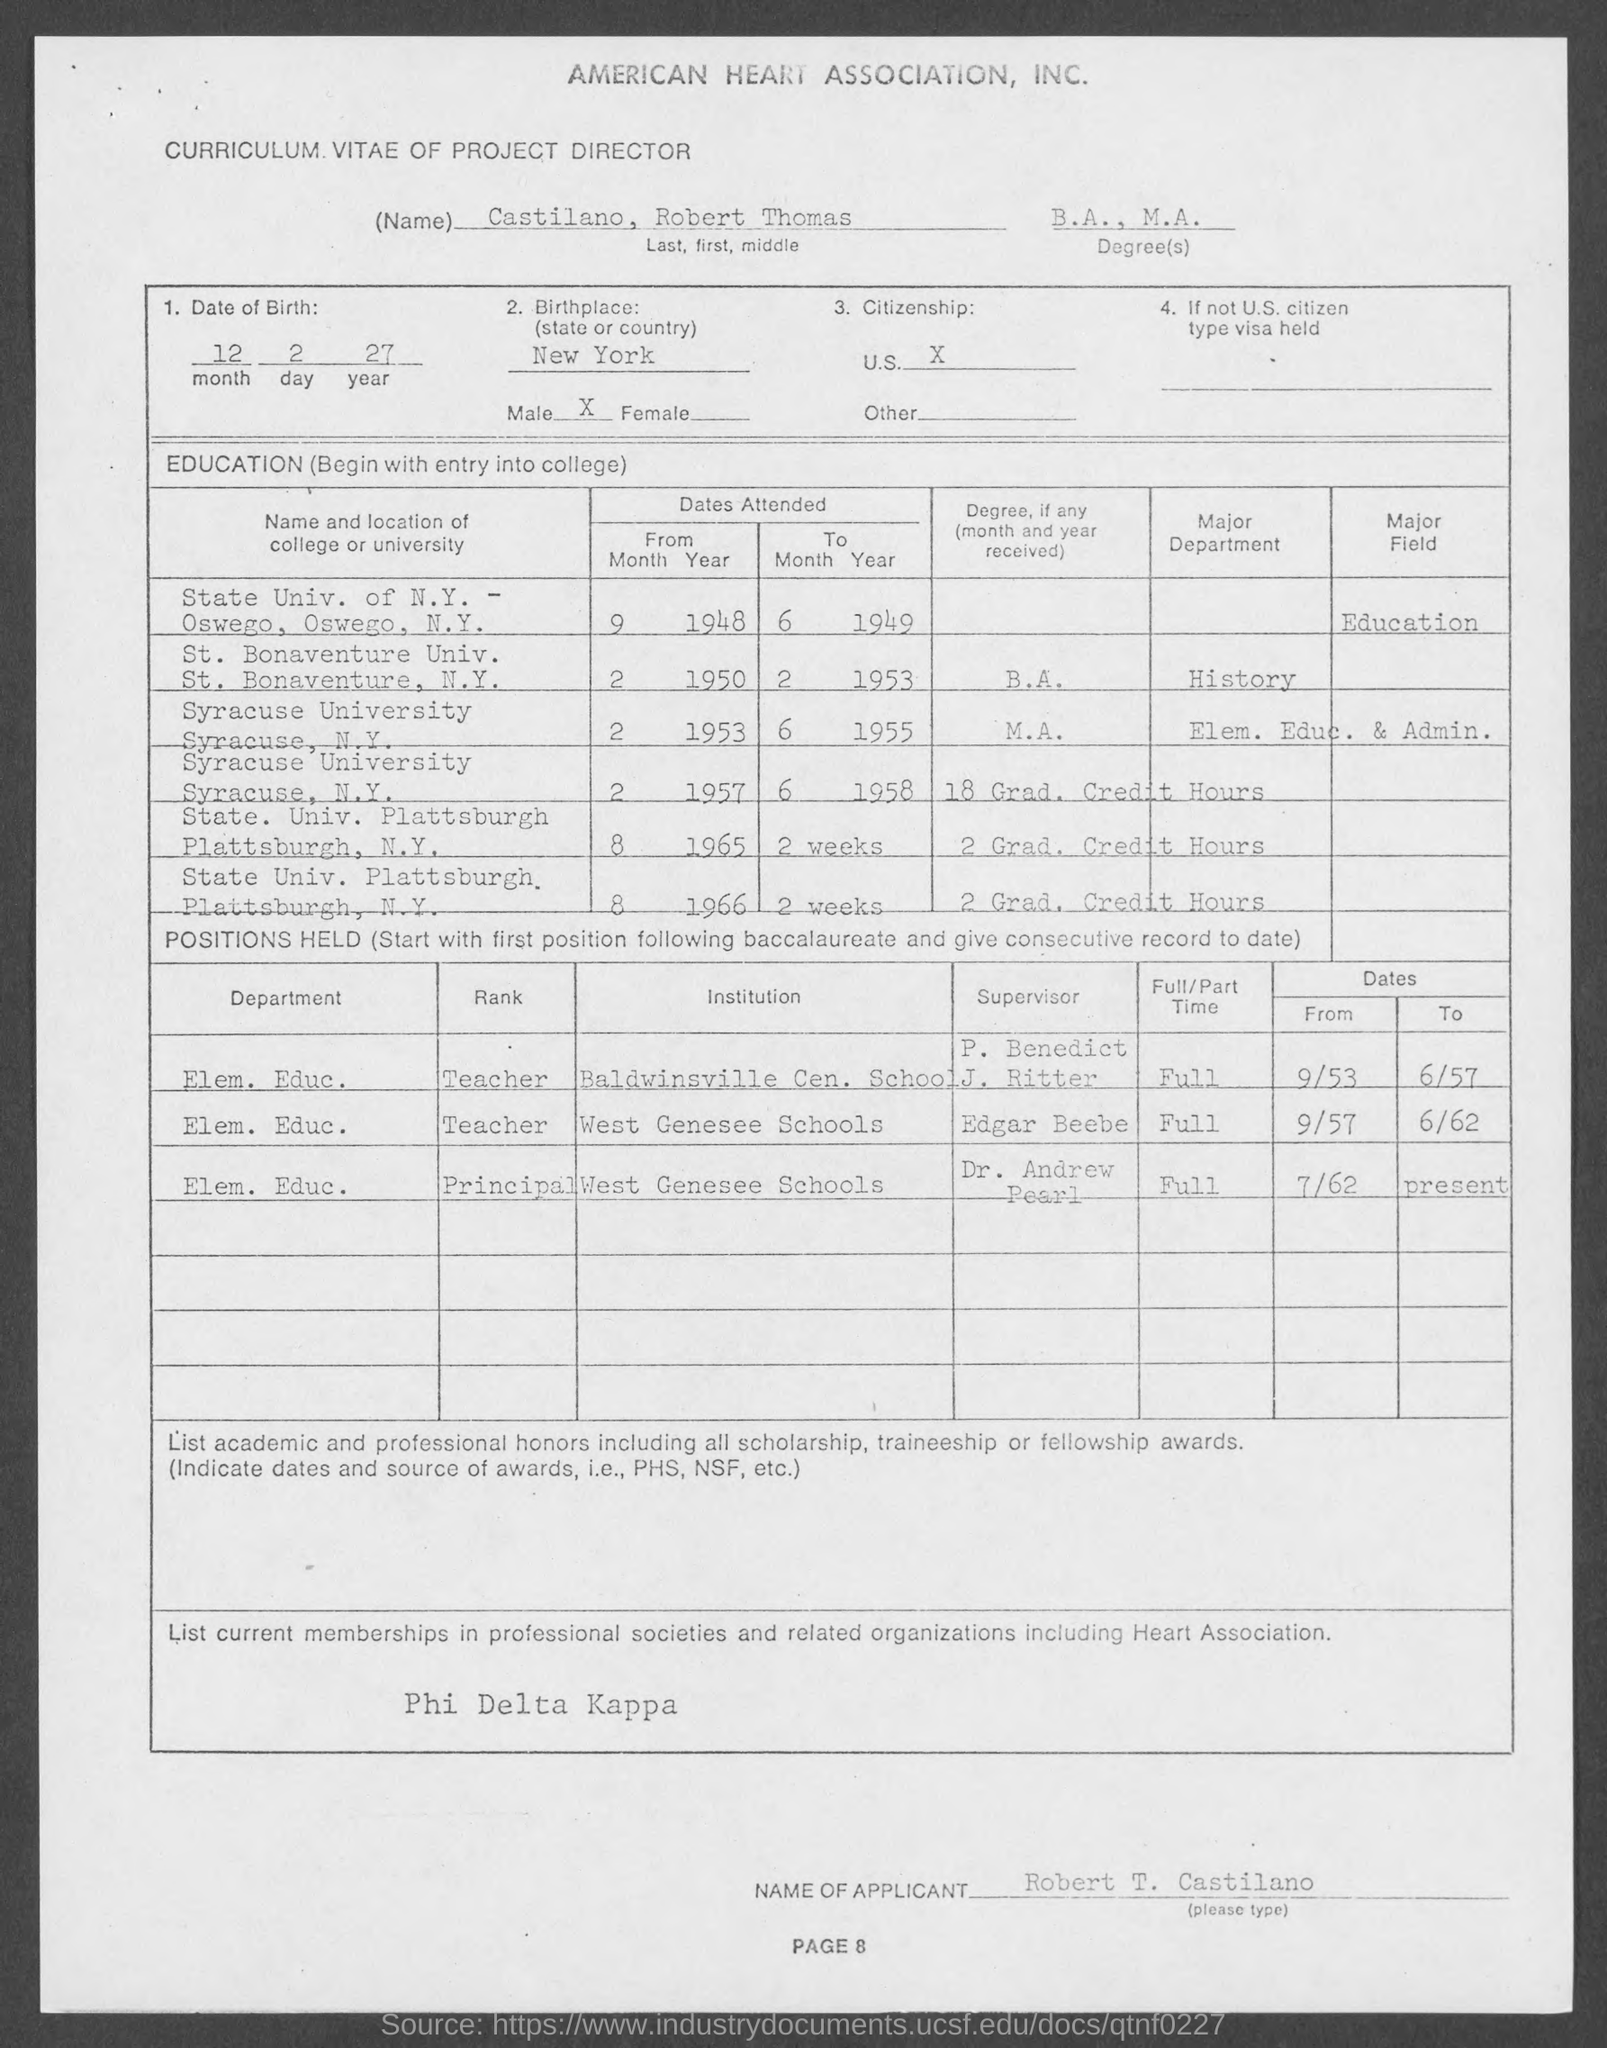Outline some significant characteristics in this image. The degrees offered are Bachelor of Arts (B.A.) and Master of Arts (M.A.). The name is Robert Thomas Castilano. The title of the document is a Curriculum Vitae of a Project Director. May 12, 2027 is the date of birth of a person. 